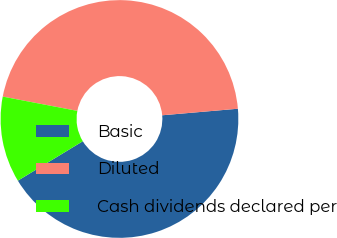Convert chart to OTSL. <chart><loc_0><loc_0><loc_500><loc_500><pie_chart><fcel>Basic<fcel>Diluted<fcel>Cash dividends declared per<nl><fcel>42.69%<fcel>45.61%<fcel>11.7%<nl></chart> 